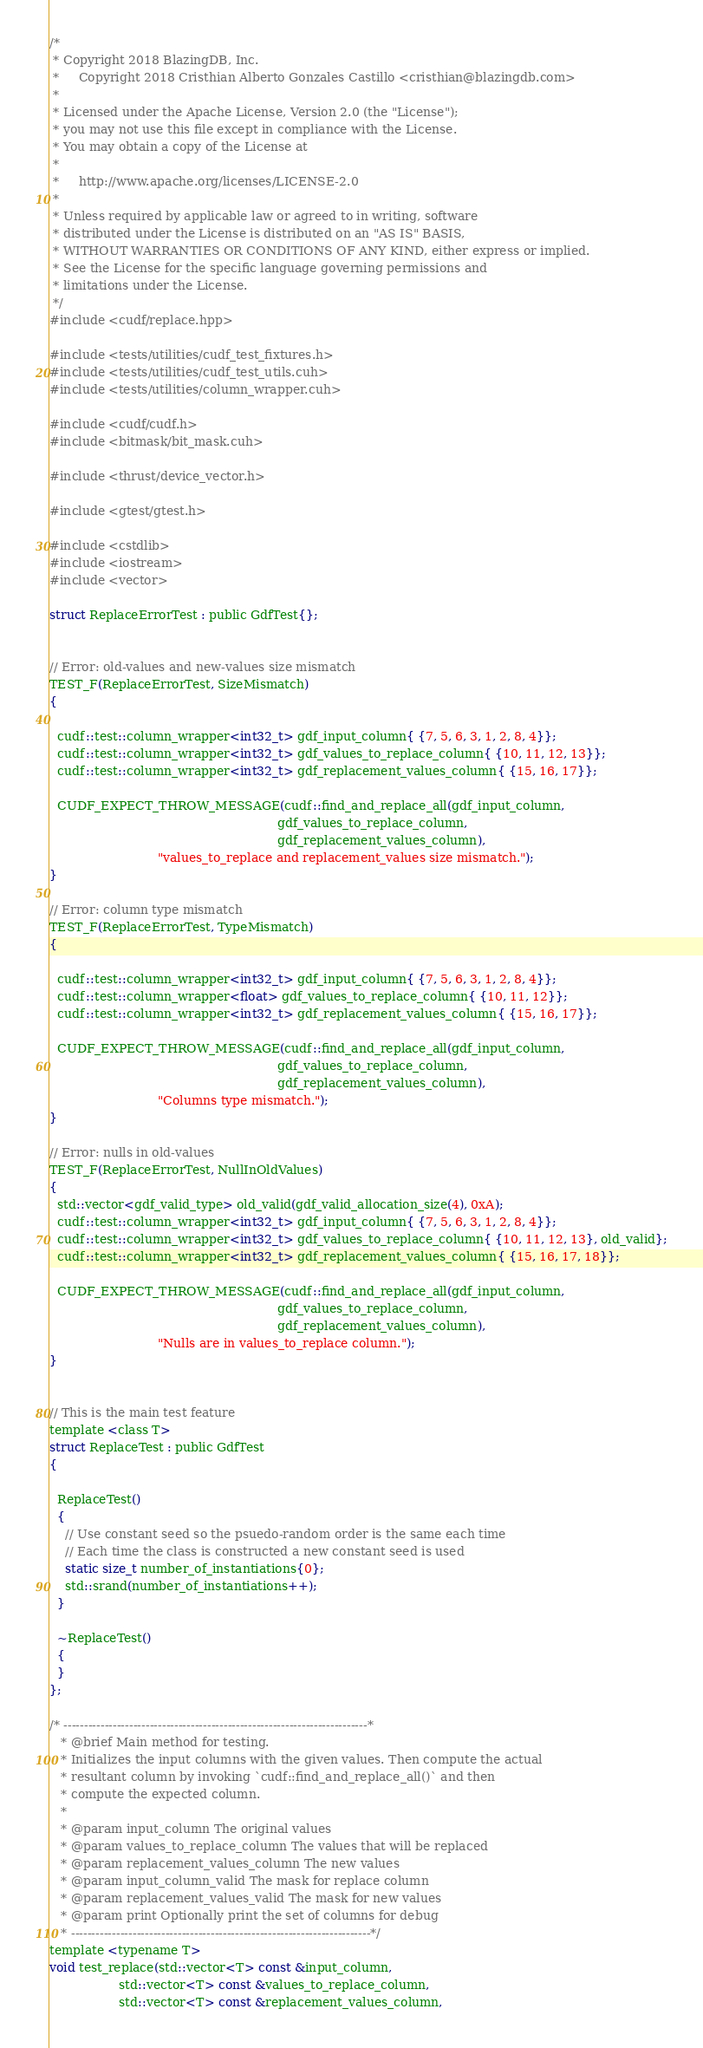Convert code to text. <code><loc_0><loc_0><loc_500><loc_500><_Cuda_>/*
 * Copyright 2018 BlazingDB, Inc.
 *     Copyright 2018 Cristhian Alberto Gonzales Castillo <cristhian@blazingdb.com>
 *
 * Licensed under the Apache License, Version 2.0 (the "License");
 * you may not use this file except in compliance with the License.
 * You may obtain a copy of the License at
 *
 *     http://www.apache.org/licenses/LICENSE-2.0
 *
 * Unless required by applicable law or agreed to in writing, software
 * distributed under the License is distributed on an "AS IS" BASIS,
 * WITHOUT WARRANTIES OR CONDITIONS OF ANY KIND, either express or implied.
 * See the License for the specific language governing permissions and
 * limitations under the License.
 */
#include <cudf/replace.hpp>

#include <tests/utilities/cudf_test_fixtures.h>
#include <tests/utilities/cudf_test_utils.cuh>
#include <tests/utilities/column_wrapper.cuh>

#include <cudf/cudf.h>
#include <bitmask/bit_mask.cuh>

#include <thrust/device_vector.h>

#include <gtest/gtest.h>

#include <cstdlib>
#include <iostream>
#include <vector>

struct ReplaceErrorTest : public GdfTest{};


// Error: old-values and new-values size mismatch
TEST_F(ReplaceErrorTest, SizeMismatch)
{

  cudf::test::column_wrapper<int32_t> gdf_input_column{ {7, 5, 6, 3, 1, 2, 8, 4}};
  cudf::test::column_wrapper<int32_t> gdf_values_to_replace_column{ {10, 11, 12, 13}};
  cudf::test::column_wrapper<int32_t> gdf_replacement_values_column{ {15, 16, 17}};

  CUDF_EXPECT_THROW_MESSAGE(cudf::find_and_replace_all(gdf_input_column,
                                                           gdf_values_to_replace_column,
                                                           gdf_replacement_values_column),
                            "values_to_replace and replacement_values size mismatch.");
}

// Error: column type mismatch
TEST_F(ReplaceErrorTest, TypeMismatch)
{

  cudf::test::column_wrapper<int32_t> gdf_input_column{ {7, 5, 6, 3, 1, 2, 8, 4}};
  cudf::test::column_wrapper<float> gdf_values_to_replace_column{ {10, 11, 12}};
  cudf::test::column_wrapper<int32_t> gdf_replacement_values_column{ {15, 16, 17}};

  CUDF_EXPECT_THROW_MESSAGE(cudf::find_and_replace_all(gdf_input_column,
                                                           gdf_values_to_replace_column,
                                                           gdf_replacement_values_column),
                            "Columns type mismatch.");
}

// Error: nulls in old-values
TEST_F(ReplaceErrorTest, NullInOldValues)
{
  std::vector<gdf_valid_type> old_valid(gdf_valid_allocation_size(4), 0xA);
  cudf::test::column_wrapper<int32_t> gdf_input_column{ {7, 5, 6, 3, 1, 2, 8, 4}};
  cudf::test::column_wrapper<int32_t> gdf_values_to_replace_column{ {10, 11, 12, 13}, old_valid};
  cudf::test::column_wrapper<int32_t> gdf_replacement_values_column{ {15, 16, 17, 18}};

  CUDF_EXPECT_THROW_MESSAGE(cudf::find_and_replace_all(gdf_input_column,
                                                           gdf_values_to_replace_column,
                                                           gdf_replacement_values_column),
                            "Nulls are in values_to_replace column.");
}


// This is the main test feature
template <class T>
struct ReplaceTest : public GdfTest
{

  ReplaceTest()
  {
    // Use constant seed so the psuedo-random order is the same each time
    // Each time the class is constructed a new constant seed is used
    static size_t number_of_instantiations{0};
    std::srand(number_of_instantiations++);
  }

  ~ReplaceTest()
  {
  }
};

/* --------------------------------------------------------------------------*
   * @brief Main method for testing.
   * Initializes the input columns with the given values. Then compute the actual
   * resultant column by invoking `cudf::find_and_replace_all()` and then
   * compute the expected column.
   *
   * @param input_column The original values
   * @param values_to_replace_column The values that will be replaced
   * @param replacement_values_column The new values
   * @param input_column_valid The mask for replace column
   * @param replacement_values_valid The mask for new values
   * @param print Optionally print the set of columns for debug
   * -------------------------------------------------------------------------*/
template <typename T>
void test_replace(std::vector<T> const &input_column,
                  std::vector<T> const &values_to_replace_column,
                  std::vector<T> const &replacement_values_column,</code> 